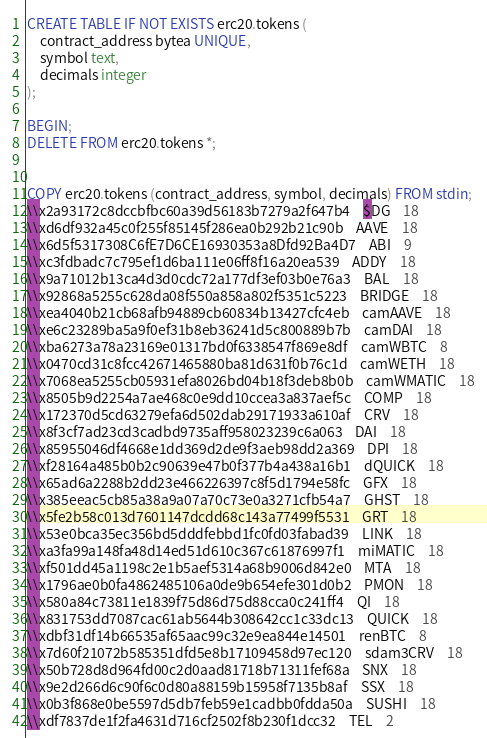Convert code to text. <code><loc_0><loc_0><loc_500><loc_500><_SQL_>CREATE TABLE IF NOT EXISTS erc20.tokens (
	contract_address bytea UNIQUE,
	symbol text,
	decimals integer
);

BEGIN;
DELETE FROM erc20.tokens *;


COPY erc20.tokens (contract_address, symbol, decimals) FROM stdin;
\\x2a93172c8dccbfbc60a39d56183b7279a2f647b4	$DG	18
\\xd6df932a45c0f255f85145f286ea0b292b21c90b	AAVE	18
\\x6d5f5317308C6fE7D6CE16930353a8Dfd92Ba4D7	ABI	9
\\xc3fdbadc7c795ef1d6ba111e06ff8f16a20ea539	ADDY	18
\\x9a71012b13ca4d3d0cdc72a177df3ef03b0e76a3	BAL	18
\\x92868a5255c628da08f550a858a802f5351c5223	BRIDGE	18
\\xea4040b21cb68afb94889cb60834b13427cfc4eb	camAAVE	18
\\xe6c23289ba5a9f0ef31b8eb36241d5c800889b7b	camDAI	18
\\xba6273a78a23169e01317bd0f6338547f869e8df	camWBTC	8
\\x0470cd31c8fcc42671465880ba81d631f0b76c1d	camWETH	18
\\x7068ea5255cb05931efa8026bd04b18f3deb8b0b	camWMATIC	18
\\x8505b9d2254a7ae468c0e9dd10ccea3a837aef5c	COMP	18
\\x172370d5cd63279efa6d502dab29171933a610af	CRV	18
\\x8f3cf7ad23cd3cadbd9735aff958023239c6a063	DAI	18
\\x85955046df4668e1dd369d2de9f3aeb98dd2a369	DPI	18
\\xf28164a485b0b2c90639e47b0f377b4a438a16b1	dQUICK	18
\\x65ad6a2288b2dd23e466226397c8f5d1794e58fc	GFX	18
\\x385eeac5cb85a38a9a07a70c73e0a3271cfb54a7	GHST	18
\\x5fe2b58c013d7601147dcdd68c143a77499f5531	GRT	18
\\x53e0bca35ec356bd5dddfebbd1fc0fd03fabad39	LINK	18
\\xa3fa99a148fa48d14ed51d610c367c61876997f1	miMATIC	18
\\xf501dd45a1198c2e1b5aef5314a68b9006d842e0	MTA	18
\\x1796ae0b0fa4862485106a0de9b654efe301d0b2	PMON	18
\\x580a84c73811e1839f75d86d75d88cca0c241ff4	QI	18
\\x831753dd7087cac61ab5644b308642cc1c33dc13	QUICK	18
\\xdbf31df14b66535af65aac99c32e9ea844e14501	renBTC	8
\\x7d60f21072b585351dfd5e8b17109458d97ec120	sdam3CRV	18
\\x50b728d8d964fd00c2d0aad81718b71311fef68a	SNX	18
\\x9e2d266d6c90f6c0d80a88159b15958f7135b8af	SSX	18
\\x0b3f868e0be5597d5db7feb59e1cadbb0fdda50a	SUSHI	18
\\xdf7837de1f2fa4631d716cf2502f8b230f1dcc32	TEL	2</code> 